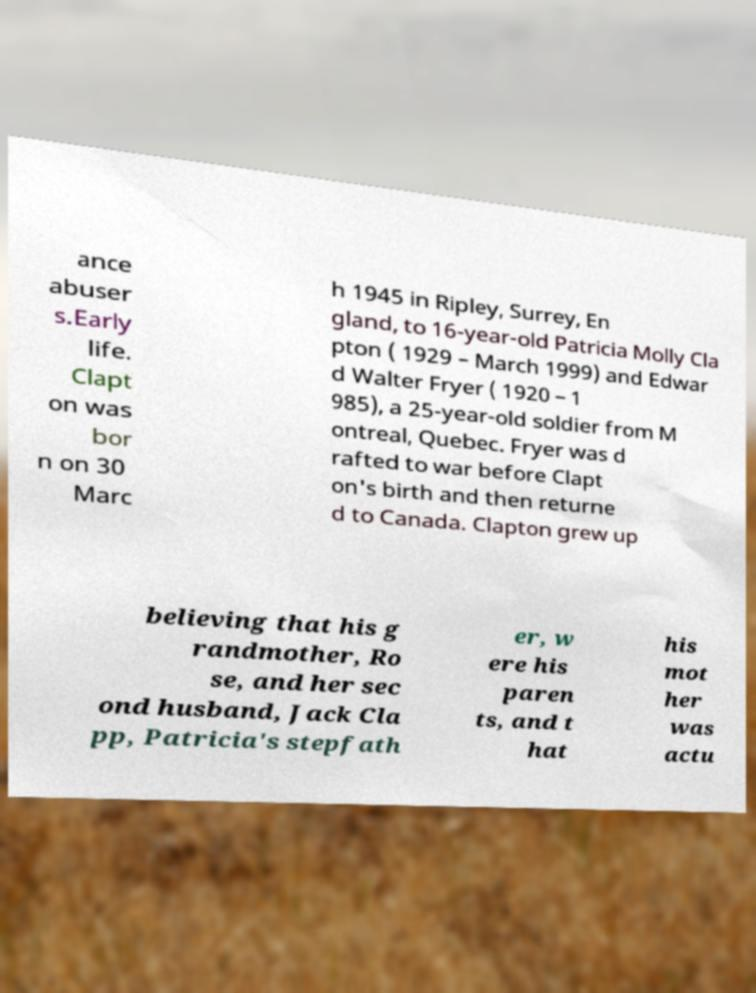For documentation purposes, I need the text within this image transcribed. Could you provide that? ance abuser s.Early life. Clapt on was bor n on 30 Marc h 1945 in Ripley, Surrey, En gland, to 16-year-old Patricia Molly Cla pton ( 1929 – March 1999) and Edwar d Walter Fryer ( 1920 – 1 985), a 25-year-old soldier from M ontreal, Quebec. Fryer was d rafted to war before Clapt on's birth and then returne d to Canada. Clapton grew up believing that his g randmother, Ro se, and her sec ond husband, Jack Cla pp, Patricia's stepfath er, w ere his paren ts, and t hat his mot her was actu 